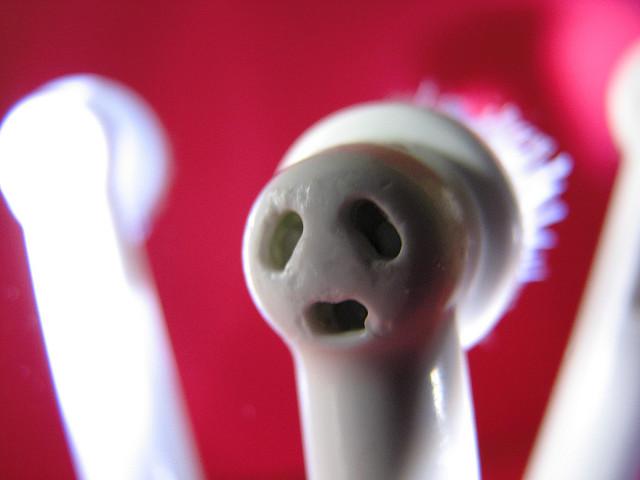What color is the background?
Be succinct. Red. What is this product?
Give a very brief answer. Toothbrush. Can you see any type of insect crawling around?
Short answer required. No. 